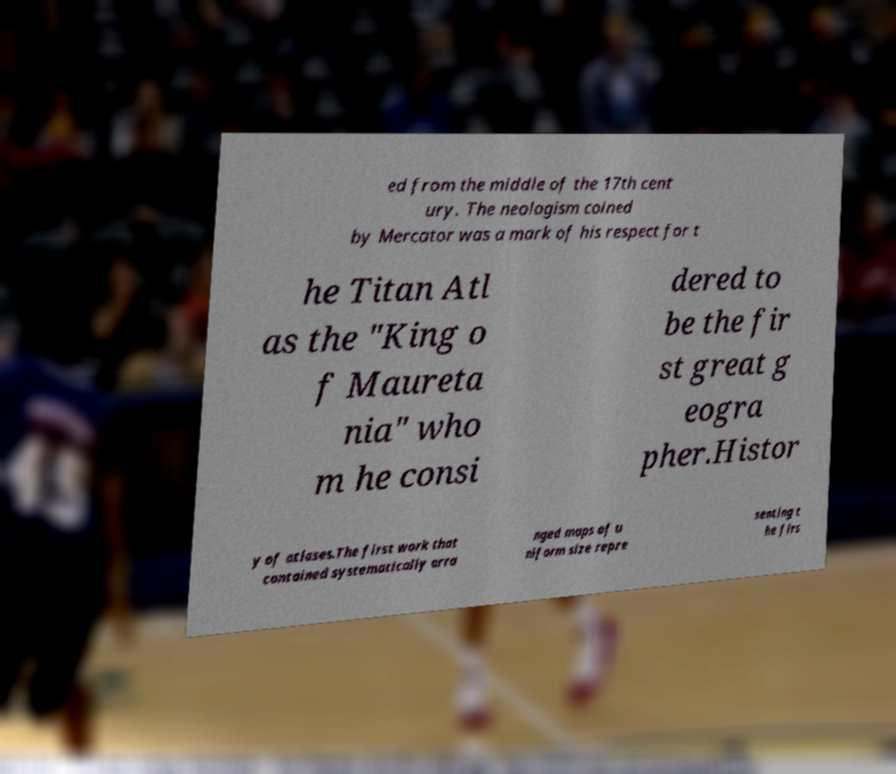For documentation purposes, I need the text within this image transcribed. Could you provide that? ed from the middle of the 17th cent ury. The neologism coined by Mercator was a mark of his respect for t he Titan Atl as the "King o f Maureta nia" who m he consi dered to be the fir st great g eogra pher.Histor y of atlases.The first work that contained systematically arra nged maps of u niform size repre senting t he firs 